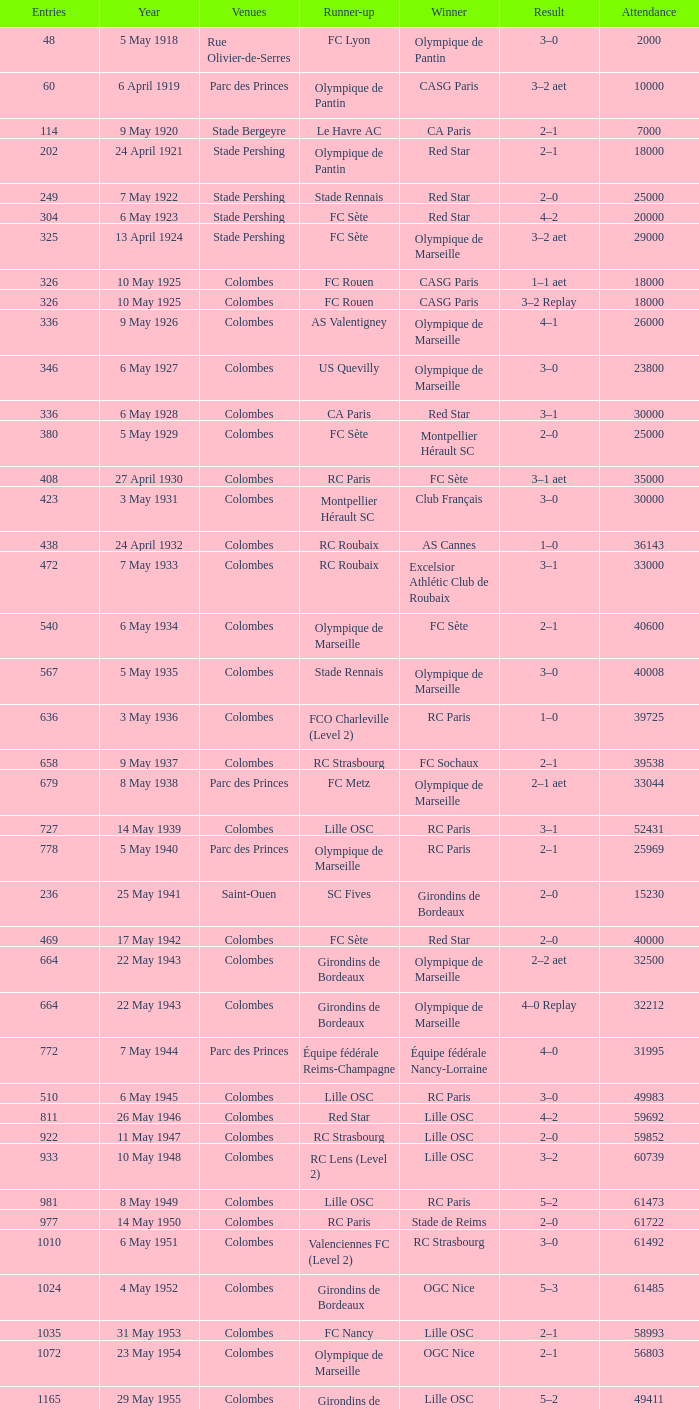How many games had red star as the runner up? 1.0. 